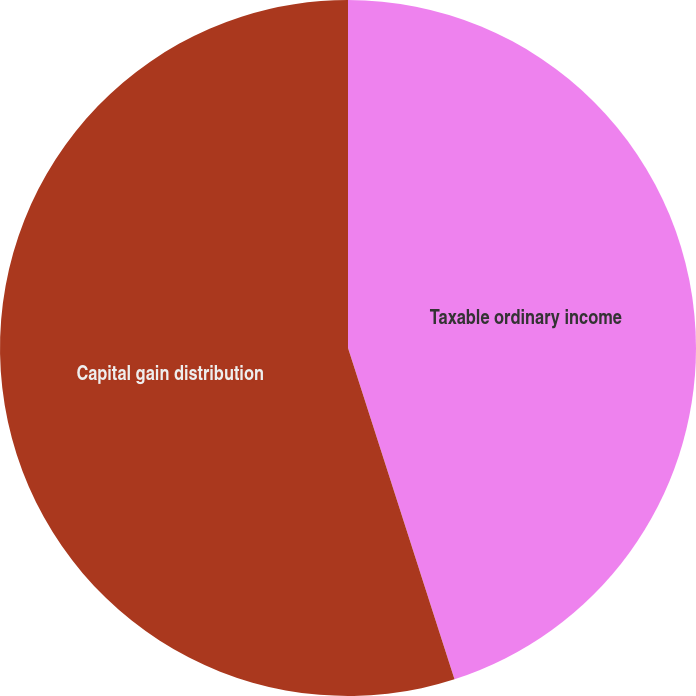Convert chart to OTSL. <chart><loc_0><loc_0><loc_500><loc_500><pie_chart><fcel>Taxable ordinary income<fcel>Capital gain distribution<nl><fcel>45.05%<fcel>54.95%<nl></chart> 